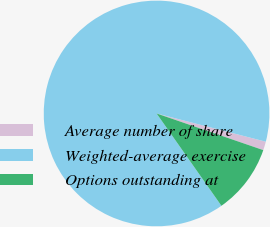Convert chart. <chart><loc_0><loc_0><loc_500><loc_500><pie_chart><fcel>Average number of share<fcel>Weighted-average exercise<fcel>Options outstanding at<nl><fcel>1.24%<fcel>88.77%<fcel>9.99%<nl></chart> 